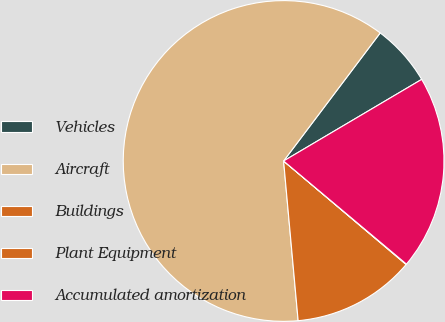Convert chart. <chart><loc_0><loc_0><loc_500><loc_500><pie_chart><fcel>Vehicles<fcel>Aircraft<fcel>Buildings<fcel>Plant Equipment<fcel>Accumulated amortization<nl><fcel>6.22%<fcel>61.73%<fcel>12.39%<fcel>0.05%<fcel>19.61%<nl></chart> 